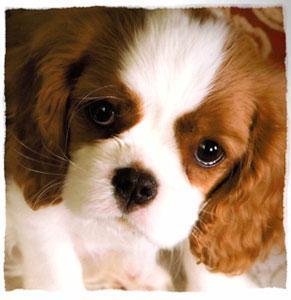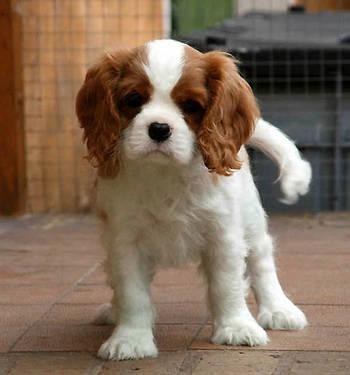The first image is the image on the left, the second image is the image on the right. Analyze the images presented: Is the assertion "There are exactly two Cavalier King Charles puppies on the pair of images." valid? Answer yes or no. Yes. The first image is the image on the left, the second image is the image on the right. Considering the images on both sides, is "There are at most two dogs." valid? Answer yes or no. Yes. 